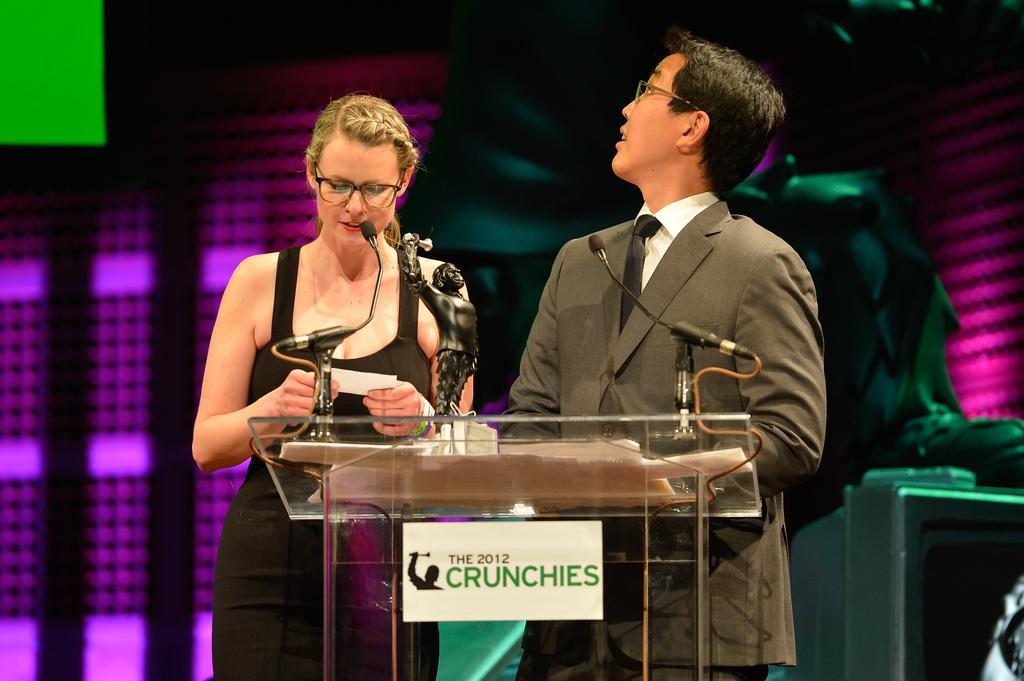In one or two sentences, can you explain what this image depicts? In this image I can see a woman wearing black dress and a man wearing white shirt, black tie and blazer are standing behind the podium and I can see few microphones and a black colored award on the podium. In the background I can see pink, green and black colored objects. 